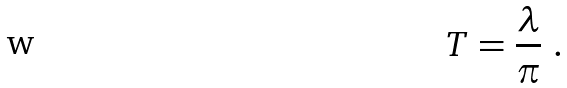Convert formula to latex. <formula><loc_0><loc_0><loc_500><loc_500>T = \frac { \lambda } { \pi } \ .</formula> 